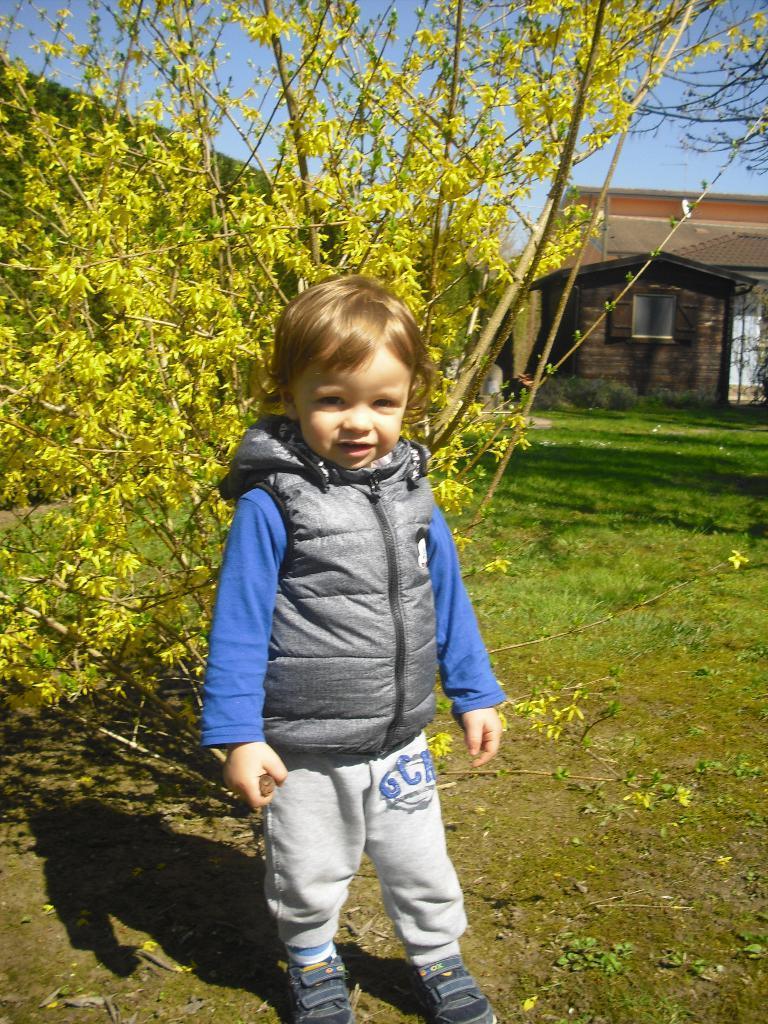Can you describe this image briefly? In this image I can see a person standing and the person is wearing ash color jacket, blue shirt and gray pant, background I can see plants in green color, a house in cream and brown color and the sky is in blue color. 